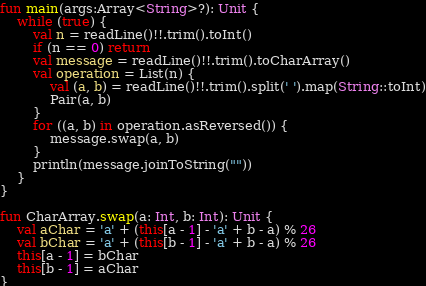<code> <loc_0><loc_0><loc_500><loc_500><_Kotlin_>fun main(args:Array<String>?): Unit {
    while (true) {
        val n = readLine()!!.trim().toInt()
        if (n == 0) return
        val message = readLine()!!.trim().toCharArray()
        val operation = List(n) {
            val (a, b) = readLine()!!.trim().split(' ').map(String::toInt)
            Pair(a, b)
        }
        for ((a, b) in operation.asReversed()) {
            message.swap(a, b)
        }
        println(message.joinToString(""))
    }
}

fun CharArray.swap(a: Int, b: Int): Unit {
    val aChar = 'a' + (this[a - 1] - 'a' + b - a) % 26
    val bChar = 'a' + (this[b - 1] - 'a' + b - a) % 26
    this[a - 1] = bChar
    this[b - 1] = aChar
}
</code> 